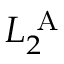Convert formula to latex. <formula><loc_0><loc_0><loc_500><loc_500>L _ { 2 } ^ { A }</formula> 